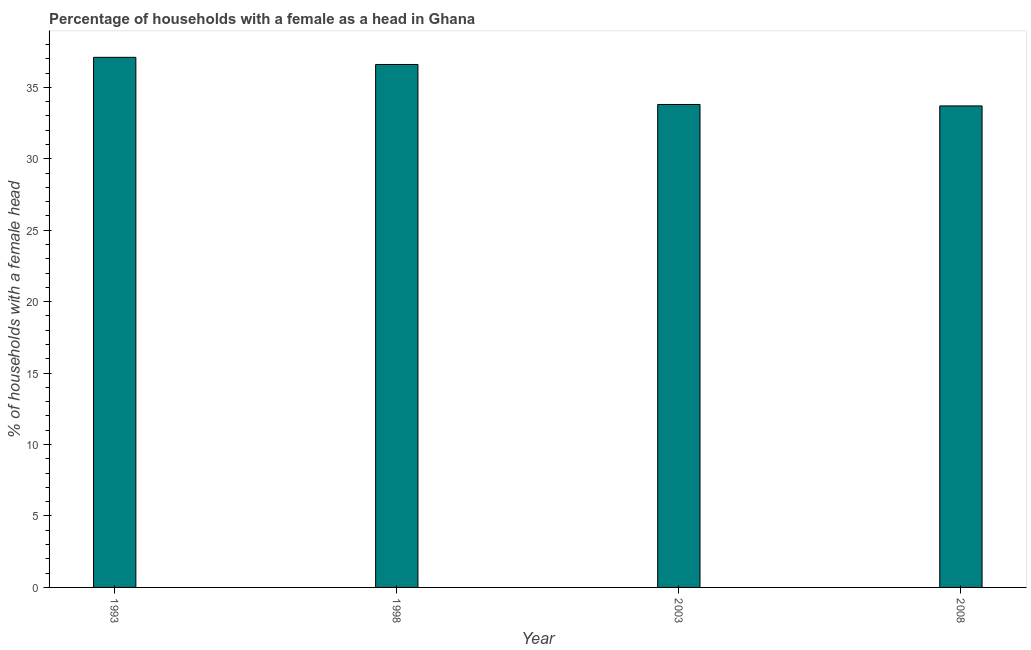Does the graph contain any zero values?
Make the answer very short. No. What is the title of the graph?
Make the answer very short. Percentage of households with a female as a head in Ghana. What is the label or title of the Y-axis?
Keep it short and to the point. % of households with a female head. What is the number of female supervised households in 1998?
Your answer should be compact. 36.6. Across all years, what is the maximum number of female supervised households?
Ensure brevity in your answer.  37.1. Across all years, what is the minimum number of female supervised households?
Offer a very short reply. 33.7. In which year was the number of female supervised households minimum?
Your response must be concise. 2008. What is the sum of the number of female supervised households?
Make the answer very short. 141.2. What is the difference between the number of female supervised households in 1998 and 2003?
Offer a terse response. 2.8. What is the average number of female supervised households per year?
Keep it short and to the point. 35.3. What is the median number of female supervised households?
Your answer should be compact. 35.2. In how many years, is the number of female supervised households greater than 22 %?
Your response must be concise. 4. Do a majority of the years between 1998 and 2003 (inclusive) have number of female supervised households greater than 21 %?
Ensure brevity in your answer.  Yes. Is the number of female supervised households in 1998 less than that in 2003?
Keep it short and to the point. No. What is the difference between the highest and the second highest number of female supervised households?
Your answer should be very brief. 0.5. Is the sum of the number of female supervised households in 2003 and 2008 greater than the maximum number of female supervised households across all years?
Provide a short and direct response. Yes. In how many years, is the number of female supervised households greater than the average number of female supervised households taken over all years?
Make the answer very short. 2. How many years are there in the graph?
Make the answer very short. 4. What is the difference between two consecutive major ticks on the Y-axis?
Your answer should be compact. 5. Are the values on the major ticks of Y-axis written in scientific E-notation?
Your answer should be very brief. No. What is the % of households with a female head of 1993?
Provide a short and direct response. 37.1. What is the % of households with a female head of 1998?
Keep it short and to the point. 36.6. What is the % of households with a female head in 2003?
Provide a succinct answer. 33.8. What is the % of households with a female head in 2008?
Give a very brief answer. 33.7. What is the difference between the % of households with a female head in 1993 and 1998?
Ensure brevity in your answer.  0.5. What is the difference between the % of households with a female head in 1993 and 2003?
Provide a short and direct response. 3.3. What is the difference between the % of households with a female head in 1993 and 2008?
Provide a short and direct response. 3.4. What is the difference between the % of households with a female head in 1998 and 2003?
Provide a succinct answer. 2.8. What is the difference between the % of households with a female head in 1998 and 2008?
Offer a terse response. 2.9. What is the difference between the % of households with a female head in 2003 and 2008?
Give a very brief answer. 0.1. What is the ratio of the % of households with a female head in 1993 to that in 2003?
Your answer should be very brief. 1.1. What is the ratio of the % of households with a female head in 1993 to that in 2008?
Make the answer very short. 1.1. What is the ratio of the % of households with a female head in 1998 to that in 2003?
Offer a very short reply. 1.08. What is the ratio of the % of households with a female head in 1998 to that in 2008?
Provide a short and direct response. 1.09. 